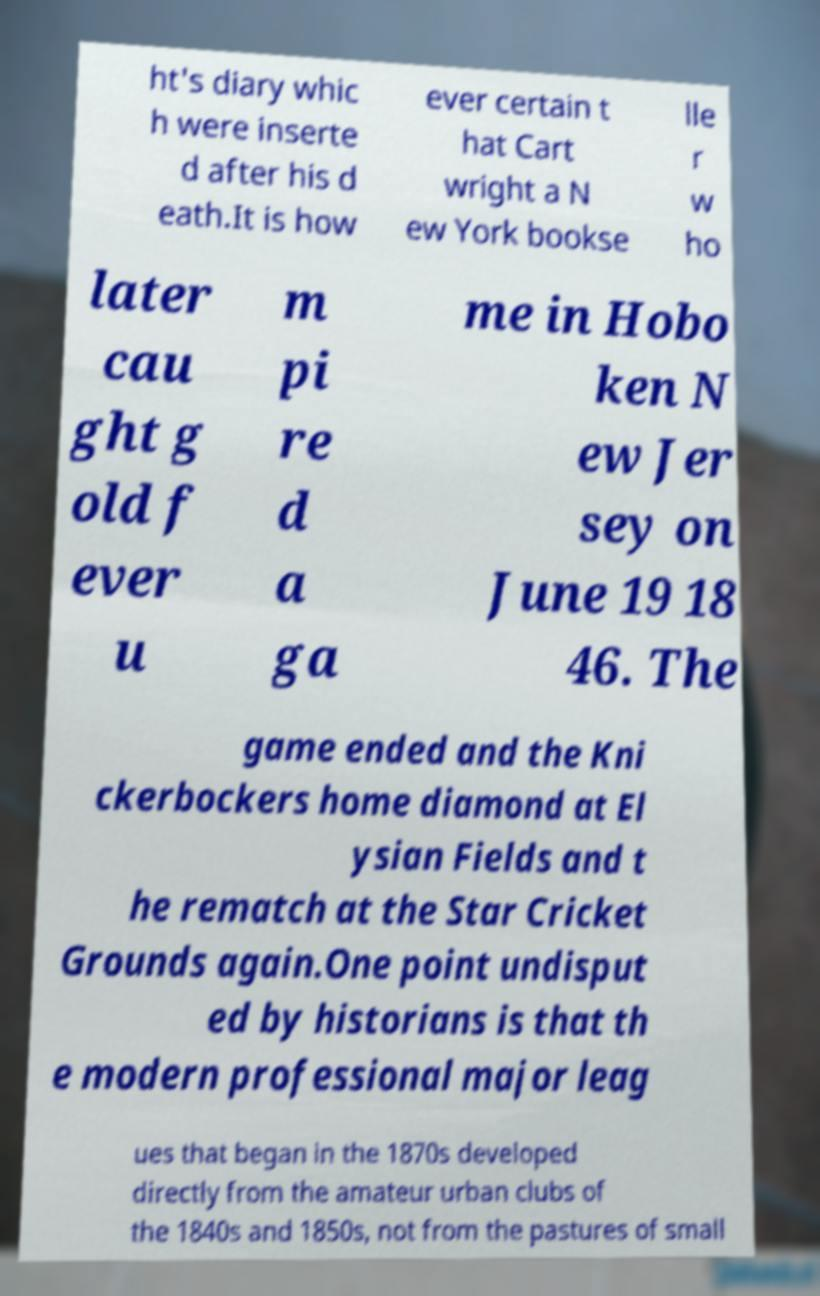Can you accurately transcribe the text from the provided image for me? ht's diary whic h were inserte d after his d eath.It is how ever certain t hat Cart wright a N ew York bookse lle r w ho later cau ght g old f ever u m pi re d a ga me in Hobo ken N ew Jer sey on June 19 18 46. The game ended and the Kni ckerbockers home diamond at El ysian Fields and t he rematch at the Star Cricket Grounds again.One point undisput ed by historians is that th e modern professional major leag ues that began in the 1870s developed directly from the amateur urban clubs of the 1840s and 1850s, not from the pastures of small 